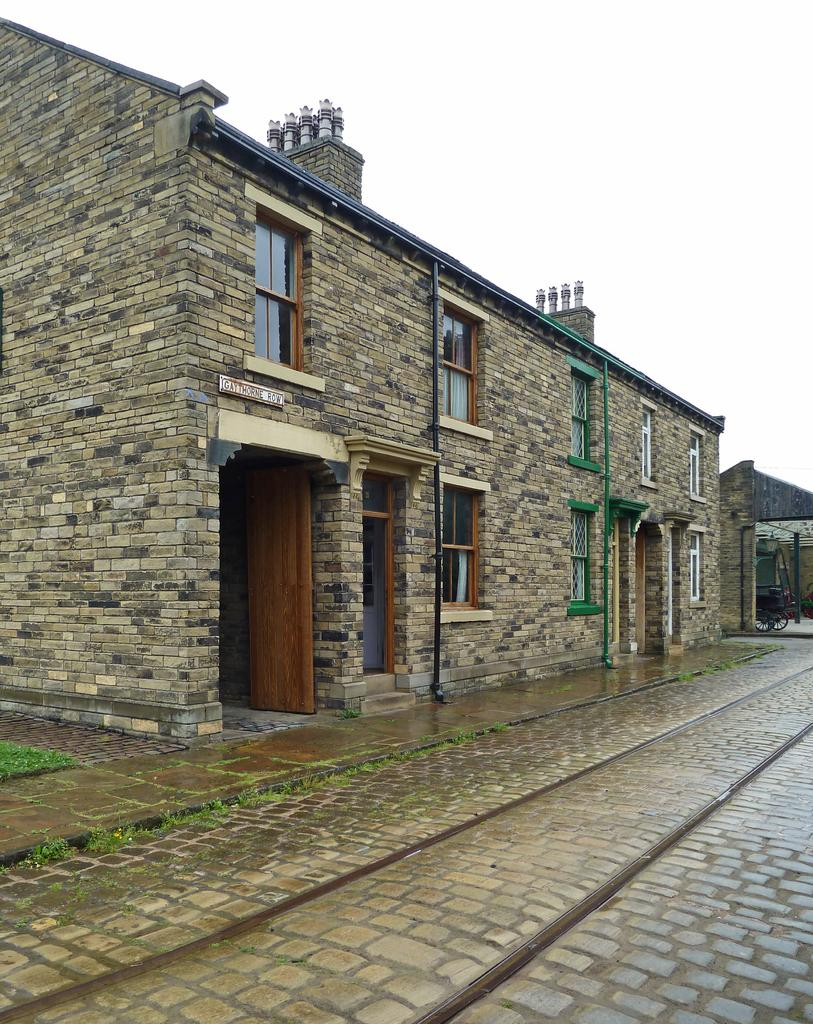What type of structures can be seen in the image? There are buildings in the image. What type of vegetation is visible in the image? There is grass visible in the image. What can be seen on the wall of one of the buildings? There are pipes on a wall in the image. What type of wood is used to construct the buildings in the image? There is no information about the type of wood used in the construction of the buildings in the image. 